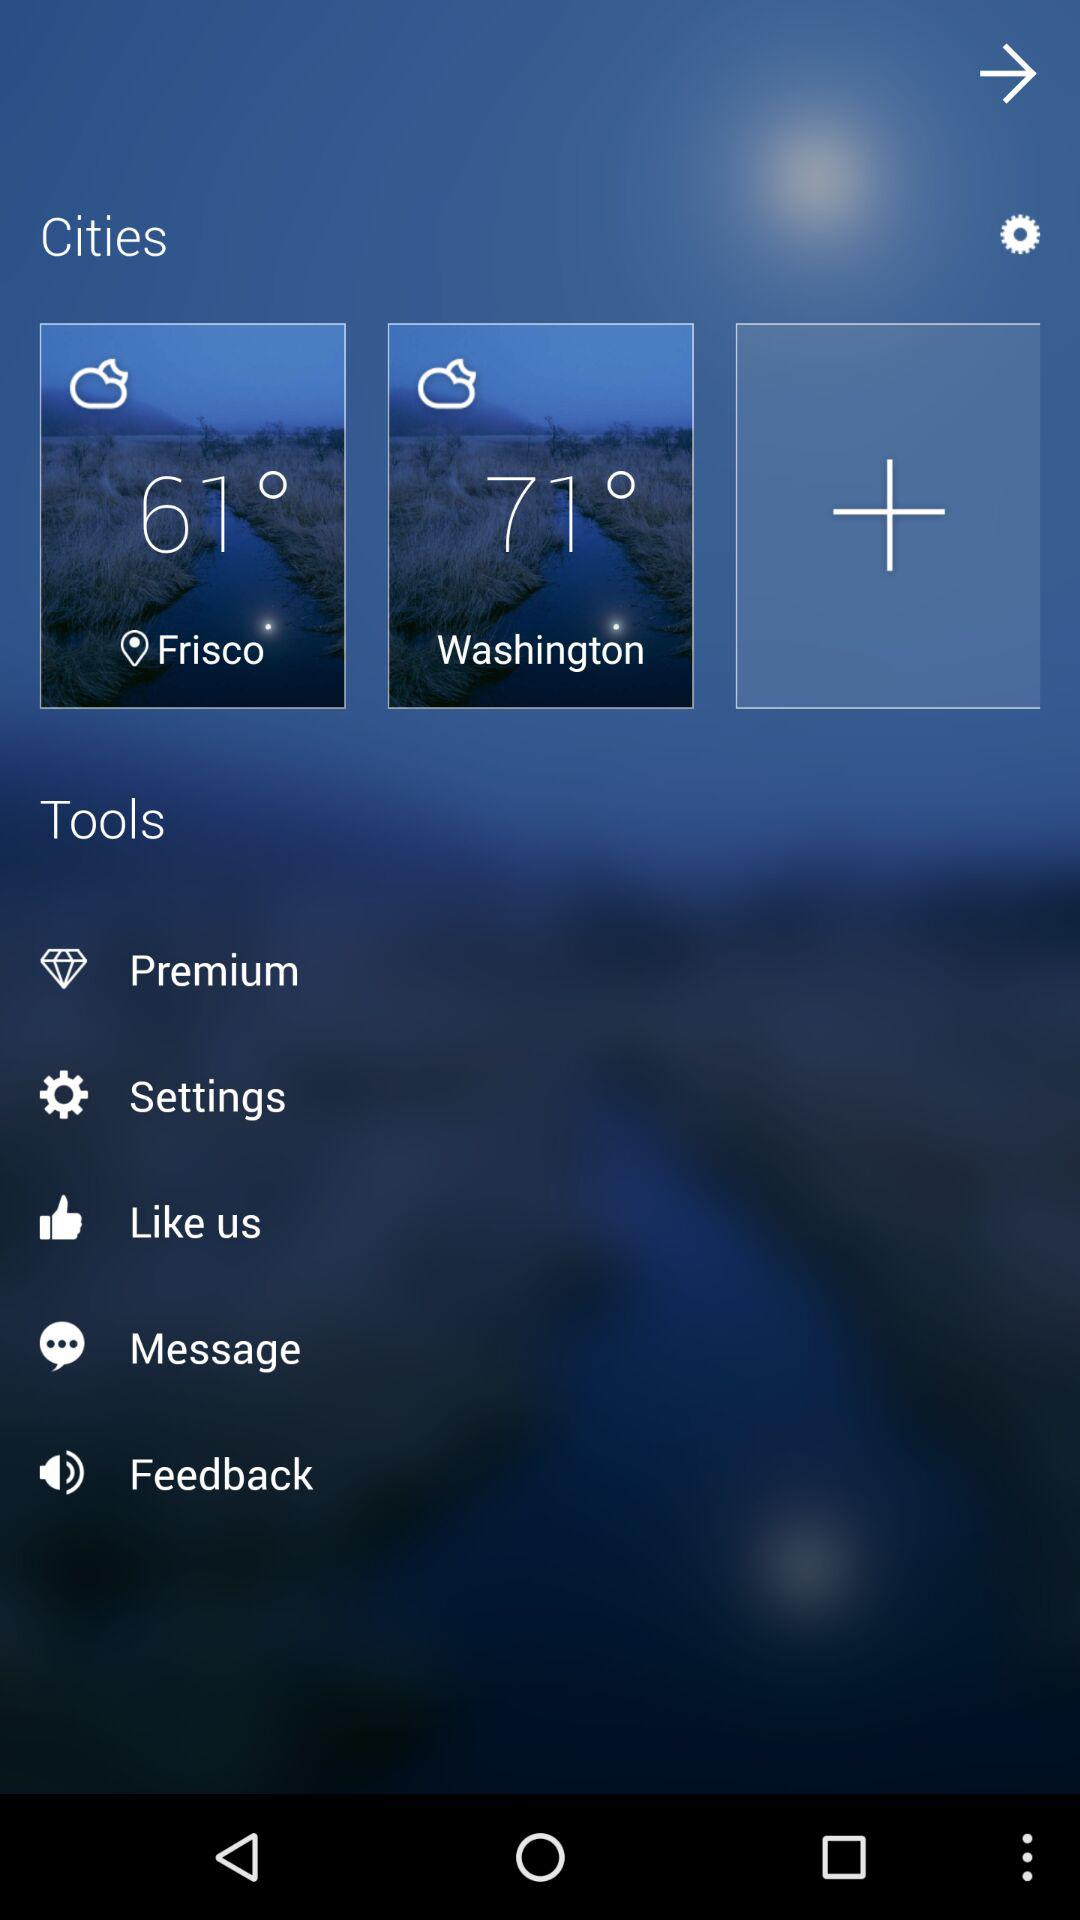What is the temperature in Frisco? The temperature in Frisco is 61 °. 